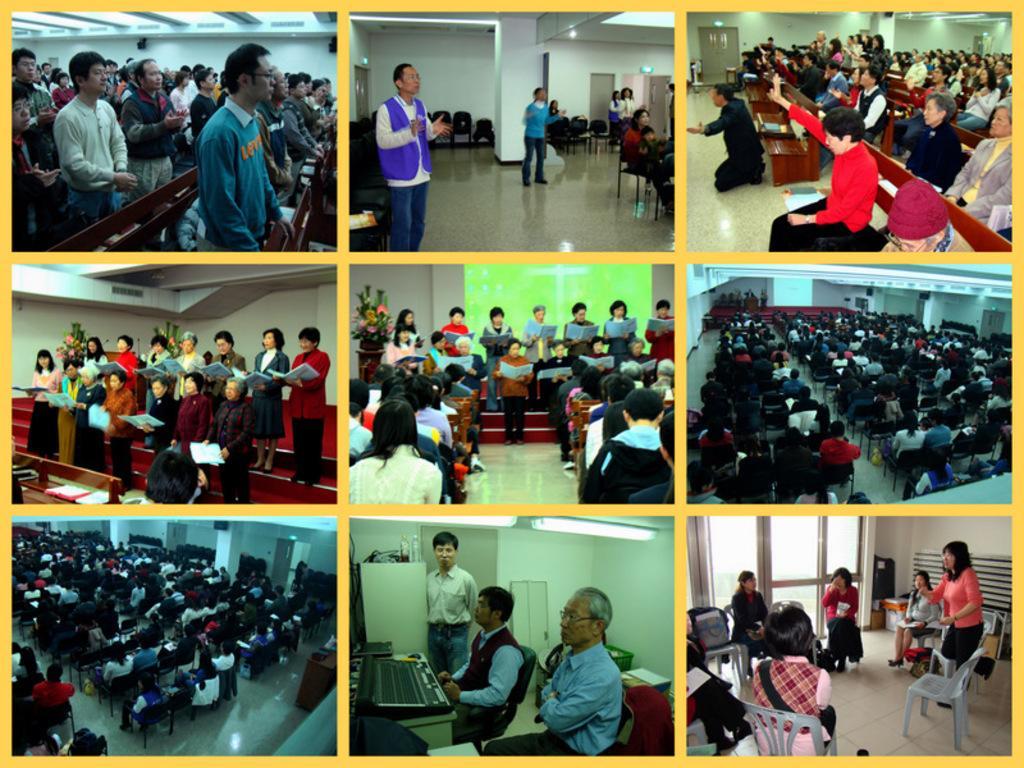Could you give a brief overview of what you see in this image? In this image there is a collage of photos. Left top of picture few persons are standing before the benches. Beside picture there are few persons are standing on the floor having few chairs and few persons are sitting on the chairs. Right top of the picture few persons are siting on the bench. Below it there is a picture having few persons sitting on the chair. Middle picture there are few persons standing and holding books in their hand and few persons are sitting on the chairs. Left side there is a picture having few persons standing and holding books in their hands. Left bottom few persons are sitting on the chairs. Right bottom a few persons are sitting on the chair and a woman is standing beside the chair. Beside there is a picture having few persons sitting on the chairs before a table having keyboard and a person is standing on the floor. 